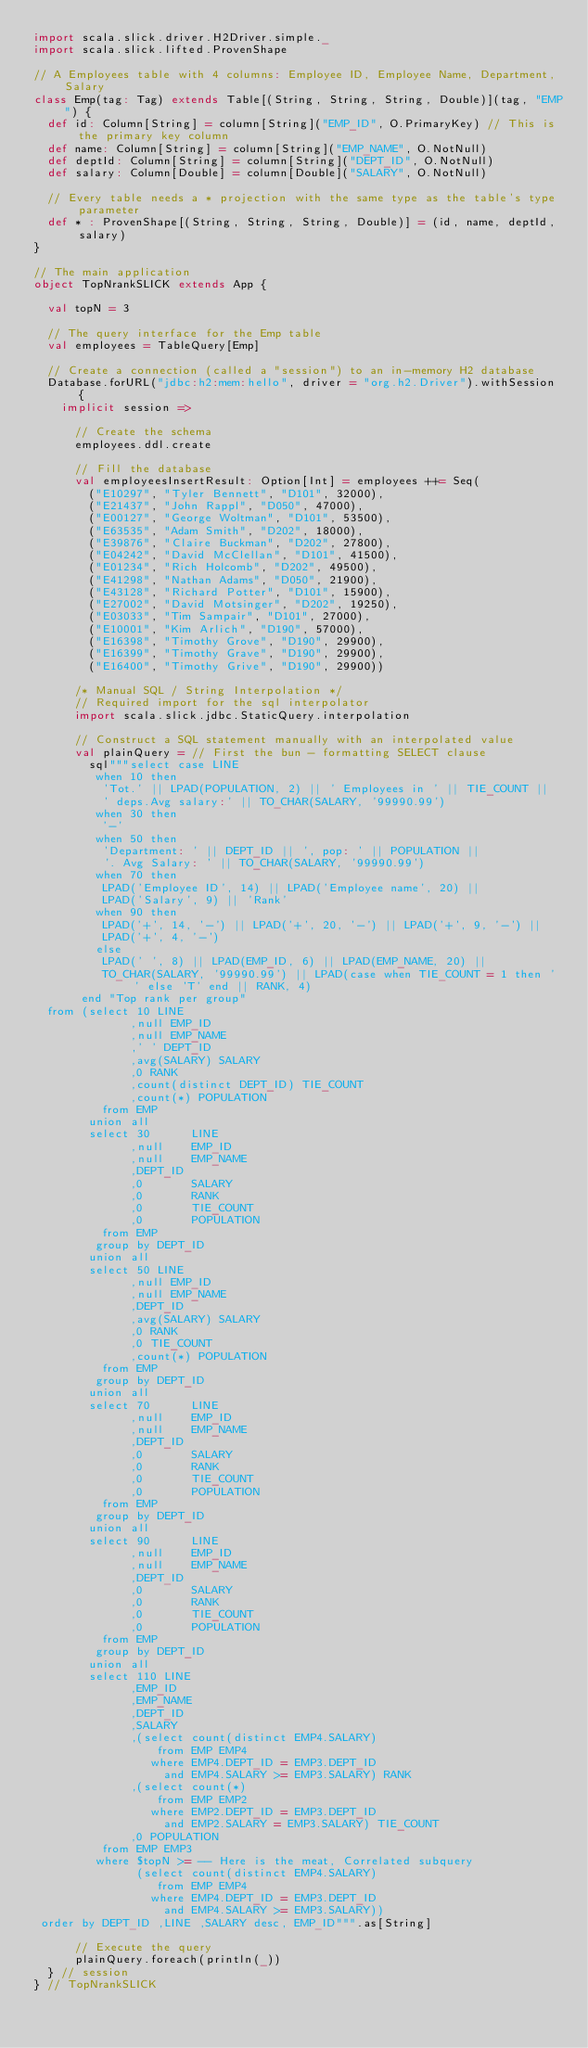Convert code to text. <code><loc_0><loc_0><loc_500><loc_500><_Scala_>import scala.slick.driver.H2Driver.simple._
import scala.slick.lifted.ProvenShape

// A Employees table with 4 columns: Employee ID, Employee Name, Department, Salary
class Emp(tag: Tag) extends Table[(String, String, String, Double)](tag, "EMP") {
  def id: Column[String] = column[String]("EMP_ID", O.PrimaryKey) // This is the primary key column
  def name: Column[String] = column[String]("EMP_NAME", O.NotNull)
  def deptId: Column[String] = column[String]("DEPT_ID", O.NotNull)
  def salary: Column[Double] = column[Double]("SALARY", O.NotNull)

  // Every table needs a * projection with the same type as the table's type parameter
  def * : ProvenShape[(String, String, String, Double)] = (id, name, deptId, salary)
}

// The main application
object TopNrankSLICK extends App {

  val topN = 3

  // The query interface for the Emp table
  val employees = TableQuery[Emp]

  // Create a connection (called a "session") to an in-memory H2 database
  Database.forURL("jdbc:h2:mem:hello", driver = "org.h2.Driver").withSession {
    implicit session =>

      // Create the schema
      employees.ddl.create

      // Fill the database
      val employeesInsertResult: Option[Int] = employees ++= Seq(
        ("E10297", "Tyler Bennett", "D101", 32000),
        ("E21437", "John Rappl", "D050", 47000),
        ("E00127", "George Woltman", "D101", 53500),
        ("E63535", "Adam Smith", "D202", 18000),
        ("E39876", "Claire Buckman", "D202", 27800),
        ("E04242", "David McClellan", "D101", 41500),
        ("E01234", "Rich Holcomb", "D202", 49500),
        ("E41298", "Nathan Adams", "D050", 21900),
        ("E43128", "Richard Potter", "D101", 15900),
        ("E27002", "David Motsinger", "D202", 19250),
        ("E03033", "Tim Sampair", "D101", 27000),
        ("E10001", "Kim Arlich", "D190", 57000),
        ("E16398", "Timothy Grove", "D190", 29900),
        ("E16399", "Timothy Grave", "D190", 29900),
        ("E16400", "Timothy Grive", "D190", 29900))

      /* Manual SQL / String Interpolation */
      // Required import for the sql interpolator
      import scala.slick.jdbc.StaticQuery.interpolation

      // Construct a SQL statement manually with an interpolated value
      val plainQuery = // First the bun - formatting SELECT clause
        sql"""select case LINE
         when 10 then
          'Tot.' || LPAD(POPULATION, 2) || ' Employees in ' || TIE_COUNT ||
          ' deps.Avg salary:' || TO_CHAR(SALARY, '99990.99')
         when 30 then
          '-'
         when 50 then
          'Department: ' || DEPT_ID || ', pop: ' || POPULATION ||
          '. Avg Salary: ' || TO_CHAR(SALARY, '99990.99')
         when 70 then
          LPAD('Employee ID', 14) || LPAD('Employee name', 20) ||
          LPAD('Salary', 9) || 'Rank'
         when 90 then
          LPAD('+', 14, '-') || LPAD('+', 20, '-') || LPAD('+', 9, '-') ||
          LPAD('+', 4, '-')
         else
          LPAD(' ', 8) || LPAD(EMP_ID, 6) || LPAD(EMP_NAME, 20) ||
          TO_CHAR(SALARY, '99990.99') || LPAD(case when TIE_COUNT = 1 then ' ' else 'T' end || RANK, 4)
       end "Top rank per group"
  from (select 10 LINE
              ,null EMP_ID
              ,null EMP_NAME
              ,' ' DEPT_ID
              ,avg(SALARY) SALARY
              ,0 RANK
              ,count(distinct DEPT_ID) TIE_COUNT
              ,count(*) POPULATION
          from EMP
        union all
        select 30      LINE
              ,null    EMP_ID
              ,null    EMP_NAME
              ,DEPT_ID
              ,0       SALARY
              ,0       RANK
              ,0       TIE_COUNT
              ,0       POPULATION
          from EMP
         group by DEPT_ID
        union all
        select 50 LINE
              ,null EMP_ID
              ,null EMP_NAME
              ,DEPT_ID
              ,avg(SALARY) SALARY
              ,0 RANK
              ,0 TIE_COUNT
              ,count(*) POPULATION
          from EMP
         group by DEPT_ID
        union all
        select 70      LINE
              ,null    EMP_ID
              ,null    EMP_NAME
              ,DEPT_ID
              ,0       SALARY
              ,0       RANK
              ,0       TIE_COUNT
              ,0       POPULATION
          from EMP
         group by DEPT_ID
        union all
        select 90      LINE
              ,null    EMP_ID
              ,null    EMP_NAME
              ,DEPT_ID
              ,0       SALARY
              ,0       RANK
              ,0       TIE_COUNT
              ,0       POPULATION
          from EMP
         group by DEPT_ID
        union all
        select 110 LINE
              ,EMP_ID
              ,EMP_NAME
              ,DEPT_ID
              ,SALARY
              ,(select count(distinct EMP4.SALARY)
                  from EMP EMP4
                 where EMP4.DEPT_ID = EMP3.DEPT_ID
                   and EMP4.SALARY >= EMP3.SALARY) RANK
              ,(select count(*)
                  from EMP EMP2
                 where EMP2.DEPT_ID = EMP3.DEPT_ID
                   and EMP2.SALARY = EMP3.SALARY) TIE_COUNT
              ,0 POPULATION
          from EMP EMP3
         where $topN >= -- Here is the meat, Correlated subquery
               (select count(distinct EMP4.SALARY)
                  from EMP EMP4
                 where EMP4.DEPT_ID = EMP3.DEPT_ID
                   and EMP4.SALARY >= EMP3.SALARY))
 order by DEPT_ID ,LINE ,SALARY desc, EMP_ID""".as[String]

      // Execute the query
      plainQuery.foreach(println(_))
  } // session
} // TopNrankSLICK
</code> 